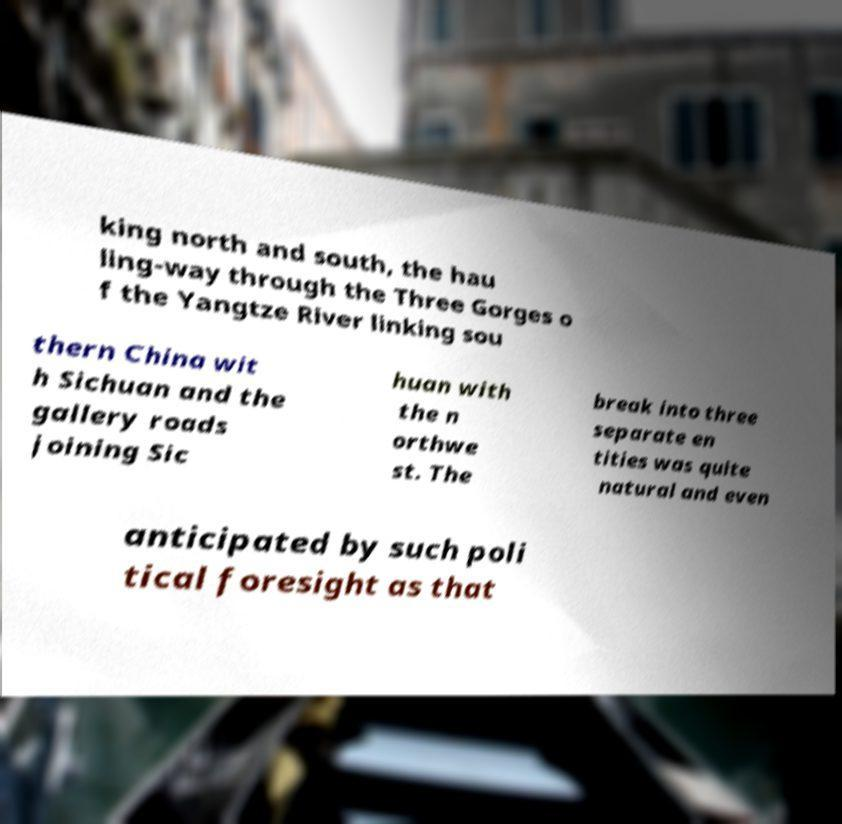What messages or text are displayed in this image? I need them in a readable, typed format. king north and south, the hau ling-way through the Three Gorges o f the Yangtze River linking sou thern China wit h Sichuan and the gallery roads joining Sic huan with the n orthwe st. The break into three separate en tities was quite natural and even anticipated by such poli tical foresight as that 